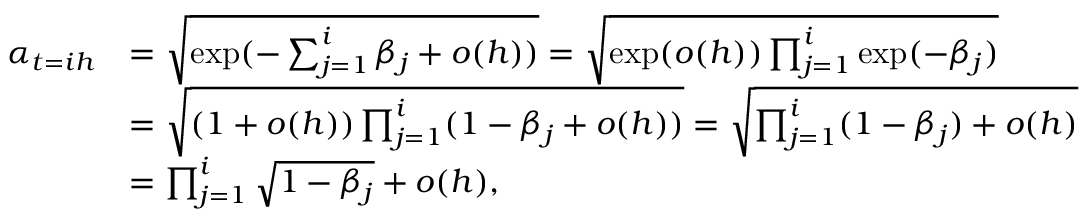Convert formula to latex. <formula><loc_0><loc_0><loc_500><loc_500>\begin{array} { r l } { \alpha _ { t = i h } } & { = \sqrt { \exp ( - \sum _ { j = 1 } ^ { i } \beta _ { j } + o ( h ) ) } = \sqrt { \exp ( o ( h ) ) \prod _ { j = 1 } ^ { i } \exp ( - \beta _ { j } ) } } \\ & { = \sqrt { ( 1 + o ( h ) ) \prod _ { j = 1 } ^ { i } ( 1 - \beta _ { j } + o ( h ) ) } = \sqrt { \prod _ { j = 1 } ^ { i } ( 1 - \beta _ { j } ) + o ( h ) } } \\ & { = \prod _ { j = 1 } ^ { i } \sqrt { 1 - \beta _ { j } } + o ( h ) , } \end{array}</formula> 